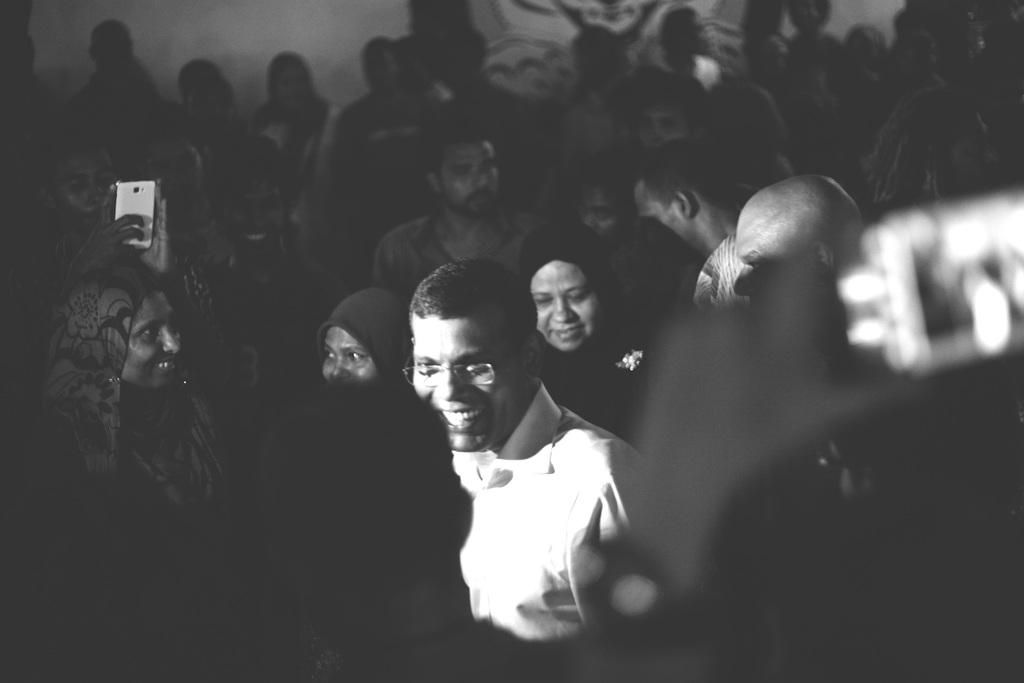What is the color scheme of the image? The image is black and white. Who is the main subject in the image? A: There is a person in the center of the image. What is the person in the center wearing? The person is wearing a white color shirt. What accessory is the person in the center wearing? The person is wearing spectacles. How many people are visible around the person in the center? There are many people around the person in the center. Reasoning: Let's think step by step by step in order to produce the conversation. We start by identifying the color scheme of the image, which is black and white. Then, we focus on the main subject, which is the person in the center. We describe the person's clothing and accessories, as well as the presence of other people in the image. Each question is designed to elicit a specific detail about the image that is known from the provided facts. Absurd Question/Answer: What type of cattle can be seen in the image? There are no cattle present in the image. What kind of humor can be observed in the image? There is no humor depicted in the image; it is a straightforward photograph of a person and a group of people. What type of jar can be seen in the image? There are no jars present in the image. 